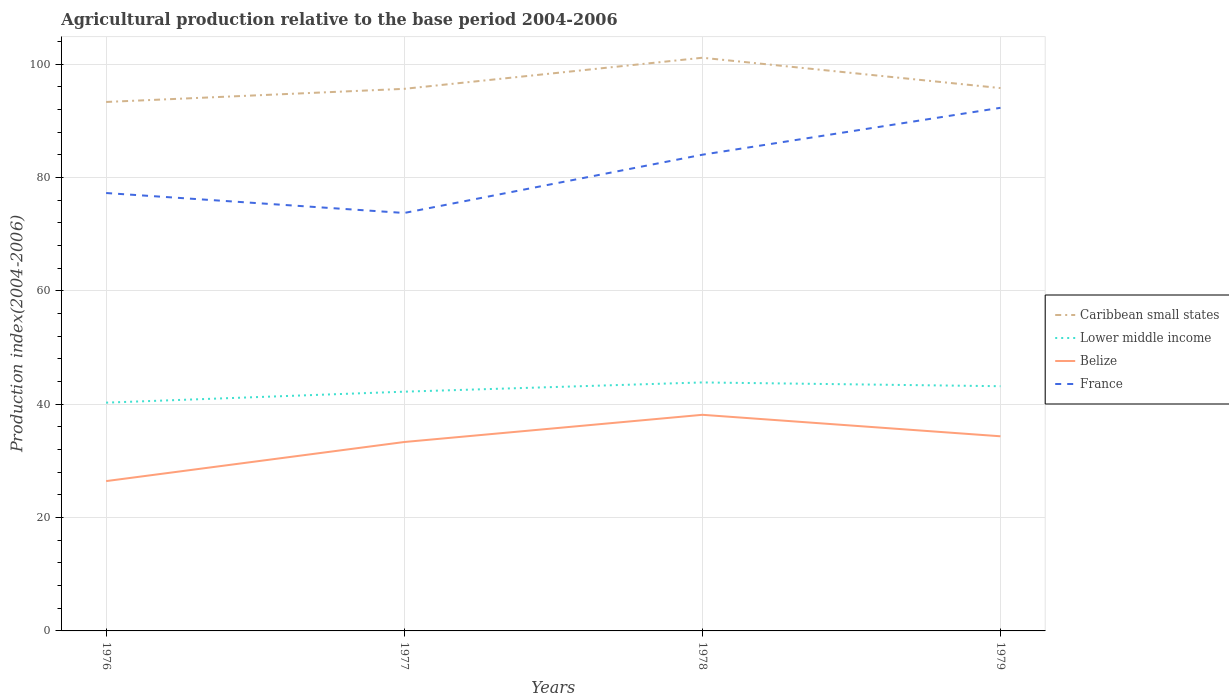How many different coloured lines are there?
Provide a short and direct response. 4. Across all years, what is the maximum agricultural production index in France?
Provide a short and direct response. 73.76. In which year was the agricultural production index in Caribbean small states maximum?
Offer a terse response. 1976. What is the total agricultural production index in France in the graph?
Provide a succinct answer. -6.76. What is the difference between the highest and the lowest agricultural production index in France?
Your answer should be very brief. 2. How many years are there in the graph?
Provide a succinct answer. 4. What is the difference between two consecutive major ticks on the Y-axis?
Give a very brief answer. 20. Does the graph contain any zero values?
Offer a very short reply. No. Where does the legend appear in the graph?
Provide a succinct answer. Center right. How many legend labels are there?
Make the answer very short. 4. What is the title of the graph?
Your answer should be compact. Agricultural production relative to the base period 2004-2006. What is the label or title of the Y-axis?
Provide a short and direct response. Production index(2004-2006). What is the Production index(2004-2006) in Caribbean small states in 1976?
Your answer should be compact. 93.35. What is the Production index(2004-2006) of Lower middle income in 1976?
Your answer should be compact. 40.29. What is the Production index(2004-2006) in Belize in 1976?
Keep it short and to the point. 26.44. What is the Production index(2004-2006) of France in 1976?
Give a very brief answer. 77.28. What is the Production index(2004-2006) of Caribbean small states in 1977?
Make the answer very short. 95.67. What is the Production index(2004-2006) in Lower middle income in 1977?
Give a very brief answer. 42.22. What is the Production index(2004-2006) of Belize in 1977?
Your response must be concise. 33.34. What is the Production index(2004-2006) of France in 1977?
Give a very brief answer. 73.76. What is the Production index(2004-2006) in Caribbean small states in 1978?
Provide a short and direct response. 101.15. What is the Production index(2004-2006) in Lower middle income in 1978?
Make the answer very short. 43.85. What is the Production index(2004-2006) in Belize in 1978?
Offer a very short reply. 38.14. What is the Production index(2004-2006) of France in 1978?
Your answer should be very brief. 84.04. What is the Production index(2004-2006) of Caribbean small states in 1979?
Give a very brief answer. 95.8. What is the Production index(2004-2006) of Lower middle income in 1979?
Ensure brevity in your answer.  43.19. What is the Production index(2004-2006) of Belize in 1979?
Give a very brief answer. 34.35. What is the Production index(2004-2006) in France in 1979?
Your answer should be compact. 92.32. Across all years, what is the maximum Production index(2004-2006) of Caribbean small states?
Your answer should be very brief. 101.15. Across all years, what is the maximum Production index(2004-2006) of Lower middle income?
Provide a succinct answer. 43.85. Across all years, what is the maximum Production index(2004-2006) of Belize?
Offer a very short reply. 38.14. Across all years, what is the maximum Production index(2004-2006) in France?
Your response must be concise. 92.32. Across all years, what is the minimum Production index(2004-2006) of Caribbean small states?
Your response must be concise. 93.35. Across all years, what is the minimum Production index(2004-2006) in Lower middle income?
Provide a short and direct response. 40.29. Across all years, what is the minimum Production index(2004-2006) of Belize?
Your answer should be compact. 26.44. Across all years, what is the minimum Production index(2004-2006) of France?
Make the answer very short. 73.76. What is the total Production index(2004-2006) in Caribbean small states in the graph?
Ensure brevity in your answer.  385.97. What is the total Production index(2004-2006) of Lower middle income in the graph?
Your answer should be very brief. 169.55. What is the total Production index(2004-2006) in Belize in the graph?
Make the answer very short. 132.27. What is the total Production index(2004-2006) in France in the graph?
Offer a very short reply. 327.4. What is the difference between the Production index(2004-2006) in Caribbean small states in 1976 and that in 1977?
Provide a succinct answer. -2.32. What is the difference between the Production index(2004-2006) of Lower middle income in 1976 and that in 1977?
Keep it short and to the point. -1.94. What is the difference between the Production index(2004-2006) in France in 1976 and that in 1977?
Offer a terse response. 3.52. What is the difference between the Production index(2004-2006) in Caribbean small states in 1976 and that in 1978?
Your answer should be very brief. -7.8. What is the difference between the Production index(2004-2006) in Lower middle income in 1976 and that in 1978?
Keep it short and to the point. -3.57. What is the difference between the Production index(2004-2006) in Belize in 1976 and that in 1978?
Your answer should be compact. -11.7. What is the difference between the Production index(2004-2006) of France in 1976 and that in 1978?
Provide a succinct answer. -6.76. What is the difference between the Production index(2004-2006) of Caribbean small states in 1976 and that in 1979?
Your answer should be very brief. -2.45. What is the difference between the Production index(2004-2006) of Lower middle income in 1976 and that in 1979?
Keep it short and to the point. -2.9. What is the difference between the Production index(2004-2006) in Belize in 1976 and that in 1979?
Provide a short and direct response. -7.91. What is the difference between the Production index(2004-2006) of France in 1976 and that in 1979?
Provide a succinct answer. -15.04. What is the difference between the Production index(2004-2006) in Caribbean small states in 1977 and that in 1978?
Offer a terse response. -5.49. What is the difference between the Production index(2004-2006) in Lower middle income in 1977 and that in 1978?
Provide a short and direct response. -1.63. What is the difference between the Production index(2004-2006) in Belize in 1977 and that in 1978?
Your response must be concise. -4.8. What is the difference between the Production index(2004-2006) of France in 1977 and that in 1978?
Offer a very short reply. -10.28. What is the difference between the Production index(2004-2006) in Caribbean small states in 1977 and that in 1979?
Make the answer very short. -0.13. What is the difference between the Production index(2004-2006) in Lower middle income in 1977 and that in 1979?
Make the answer very short. -0.96. What is the difference between the Production index(2004-2006) of Belize in 1977 and that in 1979?
Your answer should be compact. -1.01. What is the difference between the Production index(2004-2006) of France in 1977 and that in 1979?
Keep it short and to the point. -18.56. What is the difference between the Production index(2004-2006) in Caribbean small states in 1978 and that in 1979?
Offer a very short reply. 5.35. What is the difference between the Production index(2004-2006) of Lower middle income in 1978 and that in 1979?
Your answer should be very brief. 0.67. What is the difference between the Production index(2004-2006) in Belize in 1978 and that in 1979?
Provide a succinct answer. 3.79. What is the difference between the Production index(2004-2006) in France in 1978 and that in 1979?
Provide a succinct answer. -8.28. What is the difference between the Production index(2004-2006) of Caribbean small states in 1976 and the Production index(2004-2006) of Lower middle income in 1977?
Provide a short and direct response. 51.13. What is the difference between the Production index(2004-2006) in Caribbean small states in 1976 and the Production index(2004-2006) in Belize in 1977?
Make the answer very short. 60.01. What is the difference between the Production index(2004-2006) of Caribbean small states in 1976 and the Production index(2004-2006) of France in 1977?
Provide a short and direct response. 19.59. What is the difference between the Production index(2004-2006) in Lower middle income in 1976 and the Production index(2004-2006) in Belize in 1977?
Offer a very short reply. 6.95. What is the difference between the Production index(2004-2006) in Lower middle income in 1976 and the Production index(2004-2006) in France in 1977?
Your response must be concise. -33.47. What is the difference between the Production index(2004-2006) of Belize in 1976 and the Production index(2004-2006) of France in 1977?
Offer a terse response. -47.32. What is the difference between the Production index(2004-2006) of Caribbean small states in 1976 and the Production index(2004-2006) of Lower middle income in 1978?
Your answer should be compact. 49.5. What is the difference between the Production index(2004-2006) of Caribbean small states in 1976 and the Production index(2004-2006) of Belize in 1978?
Your answer should be compact. 55.21. What is the difference between the Production index(2004-2006) in Caribbean small states in 1976 and the Production index(2004-2006) in France in 1978?
Make the answer very short. 9.31. What is the difference between the Production index(2004-2006) of Lower middle income in 1976 and the Production index(2004-2006) of Belize in 1978?
Ensure brevity in your answer.  2.15. What is the difference between the Production index(2004-2006) in Lower middle income in 1976 and the Production index(2004-2006) in France in 1978?
Provide a short and direct response. -43.75. What is the difference between the Production index(2004-2006) of Belize in 1976 and the Production index(2004-2006) of France in 1978?
Your response must be concise. -57.6. What is the difference between the Production index(2004-2006) of Caribbean small states in 1976 and the Production index(2004-2006) of Lower middle income in 1979?
Ensure brevity in your answer.  50.16. What is the difference between the Production index(2004-2006) in Caribbean small states in 1976 and the Production index(2004-2006) in Belize in 1979?
Your answer should be very brief. 59. What is the difference between the Production index(2004-2006) of Caribbean small states in 1976 and the Production index(2004-2006) of France in 1979?
Your answer should be compact. 1.03. What is the difference between the Production index(2004-2006) of Lower middle income in 1976 and the Production index(2004-2006) of Belize in 1979?
Offer a terse response. 5.94. What is the difference between the Production index(2004-2006) in Lower middle income in 1976 and the Production index(2004-2006) in France in 1979?
Your answer should be very brief. -52.03. What is the difference between the Production index(2004-2006) of Belize in 1976 and the Production index(2004-2006) of France in 1979?
Offer a very short reply. -65.88. What is the difference between the Production index(2004-2006) of Caribbean small states in 1977 and the Production index(2004-2006) of Lower middle income in 1978?
Provide a succinct answer. 51.81. What is the difference between the Production index(2004-2006) of Caribbean small states in 1977 and the Production index(2004-2006) of Belize in 1978?
Offer a very short reply. 57.53. What is the difference between the Production index(2004-2006) in Caribbean small states in 1977 and the Production index(2004-2006) in France in 1978?
Make the answer very short. 11.63. What is the difference between the Production index(2004-2006) in Lower middle income in 1977 and the Production index(2004-2006) in Belize in 1978?
Offer a very short reply. 4.08. What is the difference between the Production index(2004-2006) in Lower middle income in 1977 and the Production index(2004-2006) in France in 1978?
Ensure brevity in your answer.  -41.82. What is the difference between the Production index(2004-2006) in Belize in 1977 and the Production index(2004-2006) in France in 1978?
Ensure brevity in your answer.  -50.7. What is the difference between the Production index(2004-2006) of Caribbean small states in 1977 and the Production index(2004-2006) of Lower middle income in 1979?
Ensure brevity in your answer.  52.48. What is the difference between the Production index(2004-2006) in Caribbean small states in 1977 and the Production index(2004-2006) in Belize in 1979?
Offer a very short reply. 61.32. What is the difference between the Production index(2004-2006) of Caribbean small states in 1977 and the Production index(2004-2006) of France in 1979?
Make the answer very short. 3.35. What is the difference between the Production index(2004-2006) in Lower middle income in 1977 and the Production index(2004-2006) in Belize in 1979?
Provide a short and direct response. 7.87. What is the difference between the Production index(2004-2006) of Lower middle income in 1977 and the Production index(2004-2006) of France in 1979?
Give a very brief answer. -50.1. What is the difference between the Production index(2004-2006) in Belize in 1977 and the Production index(2004-2006) in France in 1979?
Your answer should be compact. -58.98. What is the difference between the Production index(2004-2006) of Caribbean small states in 1978 and the Production index(2004-2006) of Lower middle income in 1979?
Provide a short and direct response. 57.97. What is the difference between the Production index(2004-2006) in Caribbean small states in 1978 and the Production index(2004-2006) in Belize in 1979?
Ensure brevity in your answer.  66.8. What is the difference between the Production index(2004-2006) in Caribbean small states in 1978 and the Production index(2004-2006) in France in 1979?
Ensure brevity in your answer.  8.83. What is the difference between the Production index(2004-2006) in Lower middle income in 1978 and the Production index(2004-2006) in Belize in 1979?
Offer a terse response. 9.5. What is the difference between the Production index(2004-2006) of Lower middle income in 1978 and the Production index(2004-2006) of France in 1979?
Offer a very short reply. -48.47. What is the difference between the Production index(2004-2006) in Belize in 1978 and the Production index(2004-2006) in France in 1979?
Your answer should be very brief. -54.18. What is the average Production index(2004-2006) of Caribbean small states per year?
Your answer should be compact. 96.49. What is the average Production index(2004-2006) of Lower middle income per year?
Offer a terse response. 42.39. What is the average Production index(2004-2006) of Belize per year?
Give a very brief answer. 33.07. What is the average Production index(2004-2006) of France per year?
Your response must be concise. 81.85. In the year 1976, what is the difference between the Production index(2004-2006) in Caribbean small states and Production index(2004-2006) in Lower middle income?
Provide a succinct answer. 53.06. In the year 1976, what is the difference between the Production index(2004-2006) of Caribbean small states and Production index(2004-2006) of Belize?
Give a very brief answer. 66.91. In the year 1976, what is the difference between the Production index(2004-2006) of Caribbean small states and Production index(2004-2006) of France?
Provide a short and direct response. 16.07. In the year 1976, what is the difference between the Production index(2004-2006) in Lower middle income and Production index(2004-2006) in Belize?
Your answer should be very brief. 13.85. In the year 1976, what is the difference between the Production index(2004-2006) of Lower middle income and Production index(2004-2006) of France?
Provide a succinct answer. -36.99. In the year 1976, what is the difference between the Production index(2004-2006) in Belize and Production index(2004-2006) in France?
Offer a very short reply. -50.84. In the year 1977, what is the difference between the Production index(2004-2006) in Caribbean small states and Production index(2004-2006) in Lower middle income?
Your answer should be very brief. 53.44. In the year 1977, what is the difference between the Production index(2004-2006) in Caribbean small states and Production index(2004-2006) in Belize?
Your answer should be compact. 62.33. In the year 1977, what is the difference between the Production index(2004-2006) in Caribbean small states and Production index(2004-2006) in France?
Offer a very short reply. 21.91. In the year 1977, what is the difference between the Production index(2004-2006) in Lower middle income and Production index(2004-2006) in Belize?
Provide a short and direct response. 8.88. In the year 1977, what is the difference between the Production index(2004-2006) in Lower middle income and Production index(2004-2006) in France?
Ensure brevity in your answer.  -31.54. In the year 1977, what is the difference between the Production index(2004-2006) in Belize and Production index(2004-2006) in France?
Your answer should be compact. -40.42. In the year 1978, what is the difference between the Production index(2004-2006) in Caribbean small states and Production index(2004-2006) in Lower middle income?
Offer a very short reply. 57.3. In the year 1978, what is the difference between the Production index(2004-2006) of Caribbean small states and Production index(2004-2006) of Belize?
Keep it short and to the point. 63.01. In the year 1978, what is the difference between the Production index(2004-2006) in Caribbean small states and Production index(2004-2006) in France?
Offer a very short reply. 17.11. In the year 1978, what is the difference between the Production index(2004-2006) in Lower middle income and Production index(2004-2006) in Belize?
Give a very brief answer. 5.71. In the year 1978, what is the difference between the Production index(2004-2006) in Lower middle income and Production index(2004-2006) in France?
Provide a succinct answer. -40.19. In the year 1978, what is the difference between the Production index(2004-2006) in Belize and Production index(2004-2006) in France?
Your response must be concise. -45.9. In the year 1979, what is the difference between the Production index(2004-2006) of Caribbean small states and Production index(2004-2006) of Lower middle income?
Offer a very short reply. 52.61. In the year 1979, what is the difference between the Production index(2004-2006) of Caribbean small states and Production index(2004-2006) of Belize?
Offer a terse response. 61.45. In the year 1979, what is the difference between the Production index(2004-2006) in Caribbean small states and Production index(2004-2006) in France?
Keep it short and to the point. 3.48. In the year 1979, what is the difference between the Production index(2004-2006) in Lower middle income and Production index(2004-2006) in Belize?
Offer a very short reply. 8.84. In the year 1979, what is the difference between the Production index(2004-2006) of Lower middle income and Production index(2004-2006) of France?
Provide a succinct answer. -49.13. In the year 1979, what is the difference between the Production index(2004-2006) of Belize and Production index(2004-2006) of France?
Give a very brief answer. -57.97. What is the ratio of the Production index(2004-2006) in Caribbean small states in 1976 to that in 1977?
Offer a very short reply. 0.98. What is the ratio of the Production index(2004-2006) of Lower middle income in 1976 to that in 1977?
Offer a very short reply. 0.95. What is the ratio of the Production index(2004-2006) in Belize in 1976 to that in 1977?
Your answer should be very brief. 0.79. What is the ratio of the Production index(2004-2006) in France in 1976 to that in 1977?
Your answer should be compact. 1.05. What is the ratio of the Production index(2004-2006) of Caribbean small states in 1976 to that in 1978?
Keep it short and to the point. 0.92. What is the ratio of the Production index(2004-2006) of Lower middle income in 1976 to that in 1978?
Make the answer very short. 0.92. What is the ratio of the Production index(2004-2006) in Belize in 1976 to that in 1978?
Your answer should be very brief. 0.69. What is the ratio of the Production index(2004-2006) in France in 1976 to that in 1978?
Offer a terse response. 0.92. What is the ratio of the Production index(2004-2006) of Caribbean small states in 1976 to that in 1979?
Offer a terse response. 0.97. What is the ratio of the Production index(2004-2006) in Lower middle income in 1976 to that in 1979?
Your response must be concise. 0.93. What is the ratio of the Production index(2004-2006) of Belize in 1976 to that in 1979?
Offer a terse response. 0.77. What is the ratio of the Production index(2004-2006) in France in 1976 to that in 1979?
Give a very brief answer. 0.84. What is the ratio of the Production index(2004-2006) in Caribbean small states in 1977 to that in 1978?
Ensure brevity in your answer.  0.95. What is the ratio of the Production index(2004-2006) of Lower middle income in 1977 to that in 1978?
Make the answer very short. 0.96. What is the ratio of the Production index(2004-2006) of Belize in 1977 to that in 1978?
Your answer should be very brief. 0.87. What is the ratio of the Production index(2004-2006) of France in 1977 to that in 1978?
Offer a very short reply. 0.88. What is the ratio of the Production index(2004-2006) in Lower middle income in 1977 to that in 1979?
Ensure brevity in your answer.  0.98. What is the ratio of the Production index(2004-2006) in Belize in 1977 to that in 1979?
Provide a succinct answer. 0.97. What is the ratio of the Production index(2004-2006) in France in 1977 to that in 1979?
Make the answer very short. 0.8. What is the ratio of the Production index(2004-2006) in Caribbean small states in 1978 to that in 1979?
Make the answer very short. 1.06. What is the ratio of the Production index(2004-2006) in Lower middle income in 1978 to that in 1979?
Offer a very short reply. 1.02. What is the ratio of the Production index(2004-2006) in Belize in 1978 to that in 1979?
Make the answer very short. 1.11. What is the ratio of the Production index(2004-2006) of France in 1978 to that in 1979?
Provide a succinct answer. 0.91. What is the difference between the highest and the second highest Production index(2004-2006) in Caribbean small states?
Your answer should be very brief. 5.35. What is the difference between the highest and the second highest Production index(2004-2006) of Lower middle income?
Ensure brevity in your answer.  0.67. What is the difference between the highest and the second highest Production index(2004-2006) of Belize?
Ensure brevity in your answer.  3.79. What is the difference between the highest and the second highest Production index(2004-2006) of France?
Make the answer very short. 8.28. What is the difference between the highest and the lowest Production index(2004-2006) of Caribbean small states?
Ensure brevity in your answer.  7.8. What is the difference between the highest and the lowest Production index(2004-2006) in Lower middle income?
Make the answer very short. 3.57. What is the difference between the highest and the lowest Production index(2004-2006) of France?
Your response must be concise. 18.56. 